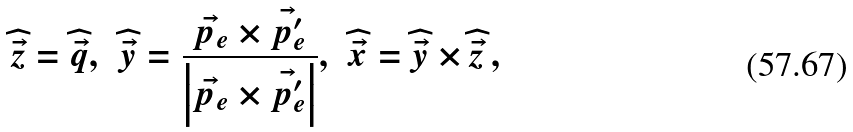<formula> <loc_0><loc_0><loc_500><loc_500>\widehat { \vec { z } } = \widehat { \vec { q } } , \, \ \widehat { \vec { y } } = \frac { \vec { p _ { e } } \times \vec { p _ { e } ^ { \prime } } } { \left | \vec { p _ { e } } \times \vec { p _ { e } ^ { \prime } } \right | } , \, \ \widehat { \vec { x } } = \widehat { \vec { y } } \times \widehat { \vec { z } } \, ,</formula> 